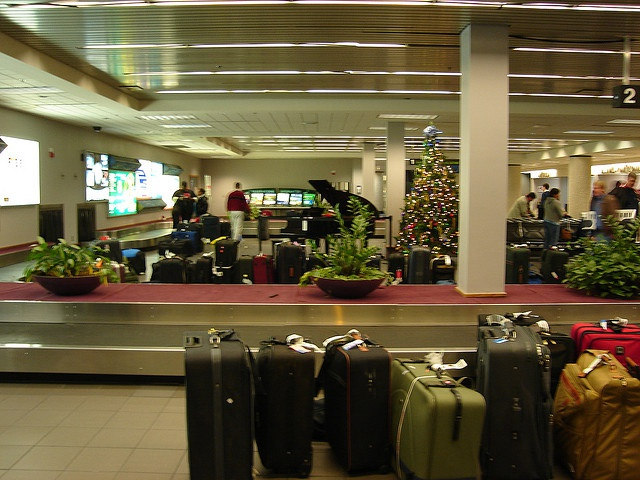Describe the objects in this image and their specific colors. I can see suitcase in darkgray, black, olive, and gray tones, suitcase in darkgray, black, and olive tones, suitcase in darkgray, black, olive, and gray tones, suitcase in darkgray, black, maroon, and olive tones, and suitcase in darkgray, black, olive, maroon, and white tones in this image. 